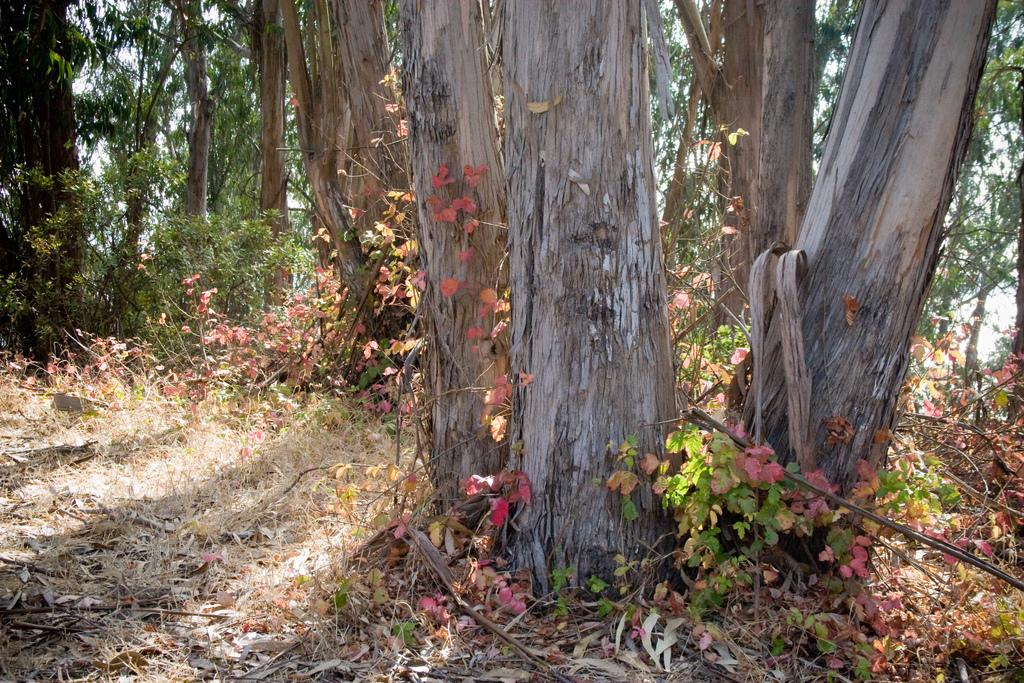What type of vegetation can be seen in the image? There are trees and plants in the image. Where are the trees and plants located? The trees and plants are present on the ground. What type of underwear is hanging from the trees in the image? There is no underwear present in the image; it only features trees and plants. 